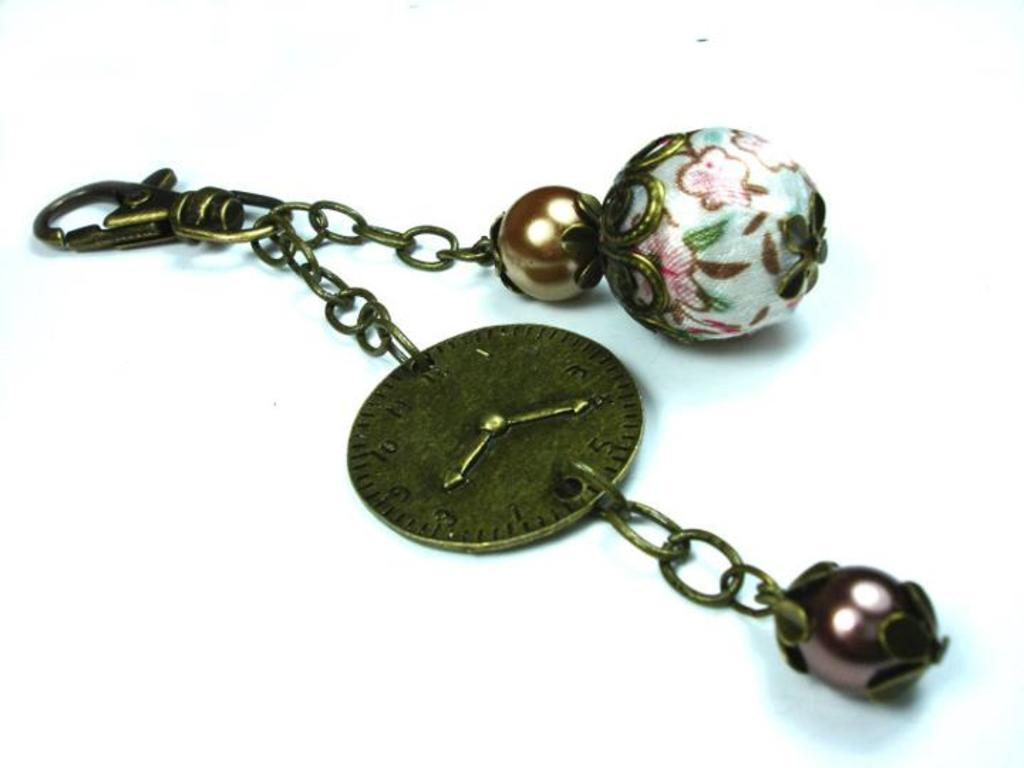What object is the main subject of the image? There is a keychain in the image. What color is the background of the image? The background of the image is white. How many bikes are parked next to the keychain in the image? There are no bikes present in the image; it only features a keychain against a white background. What type of thing is the keychain attached to in the image? The keychain is not attached to any other object in the image; it is simply displayed against a white background. 